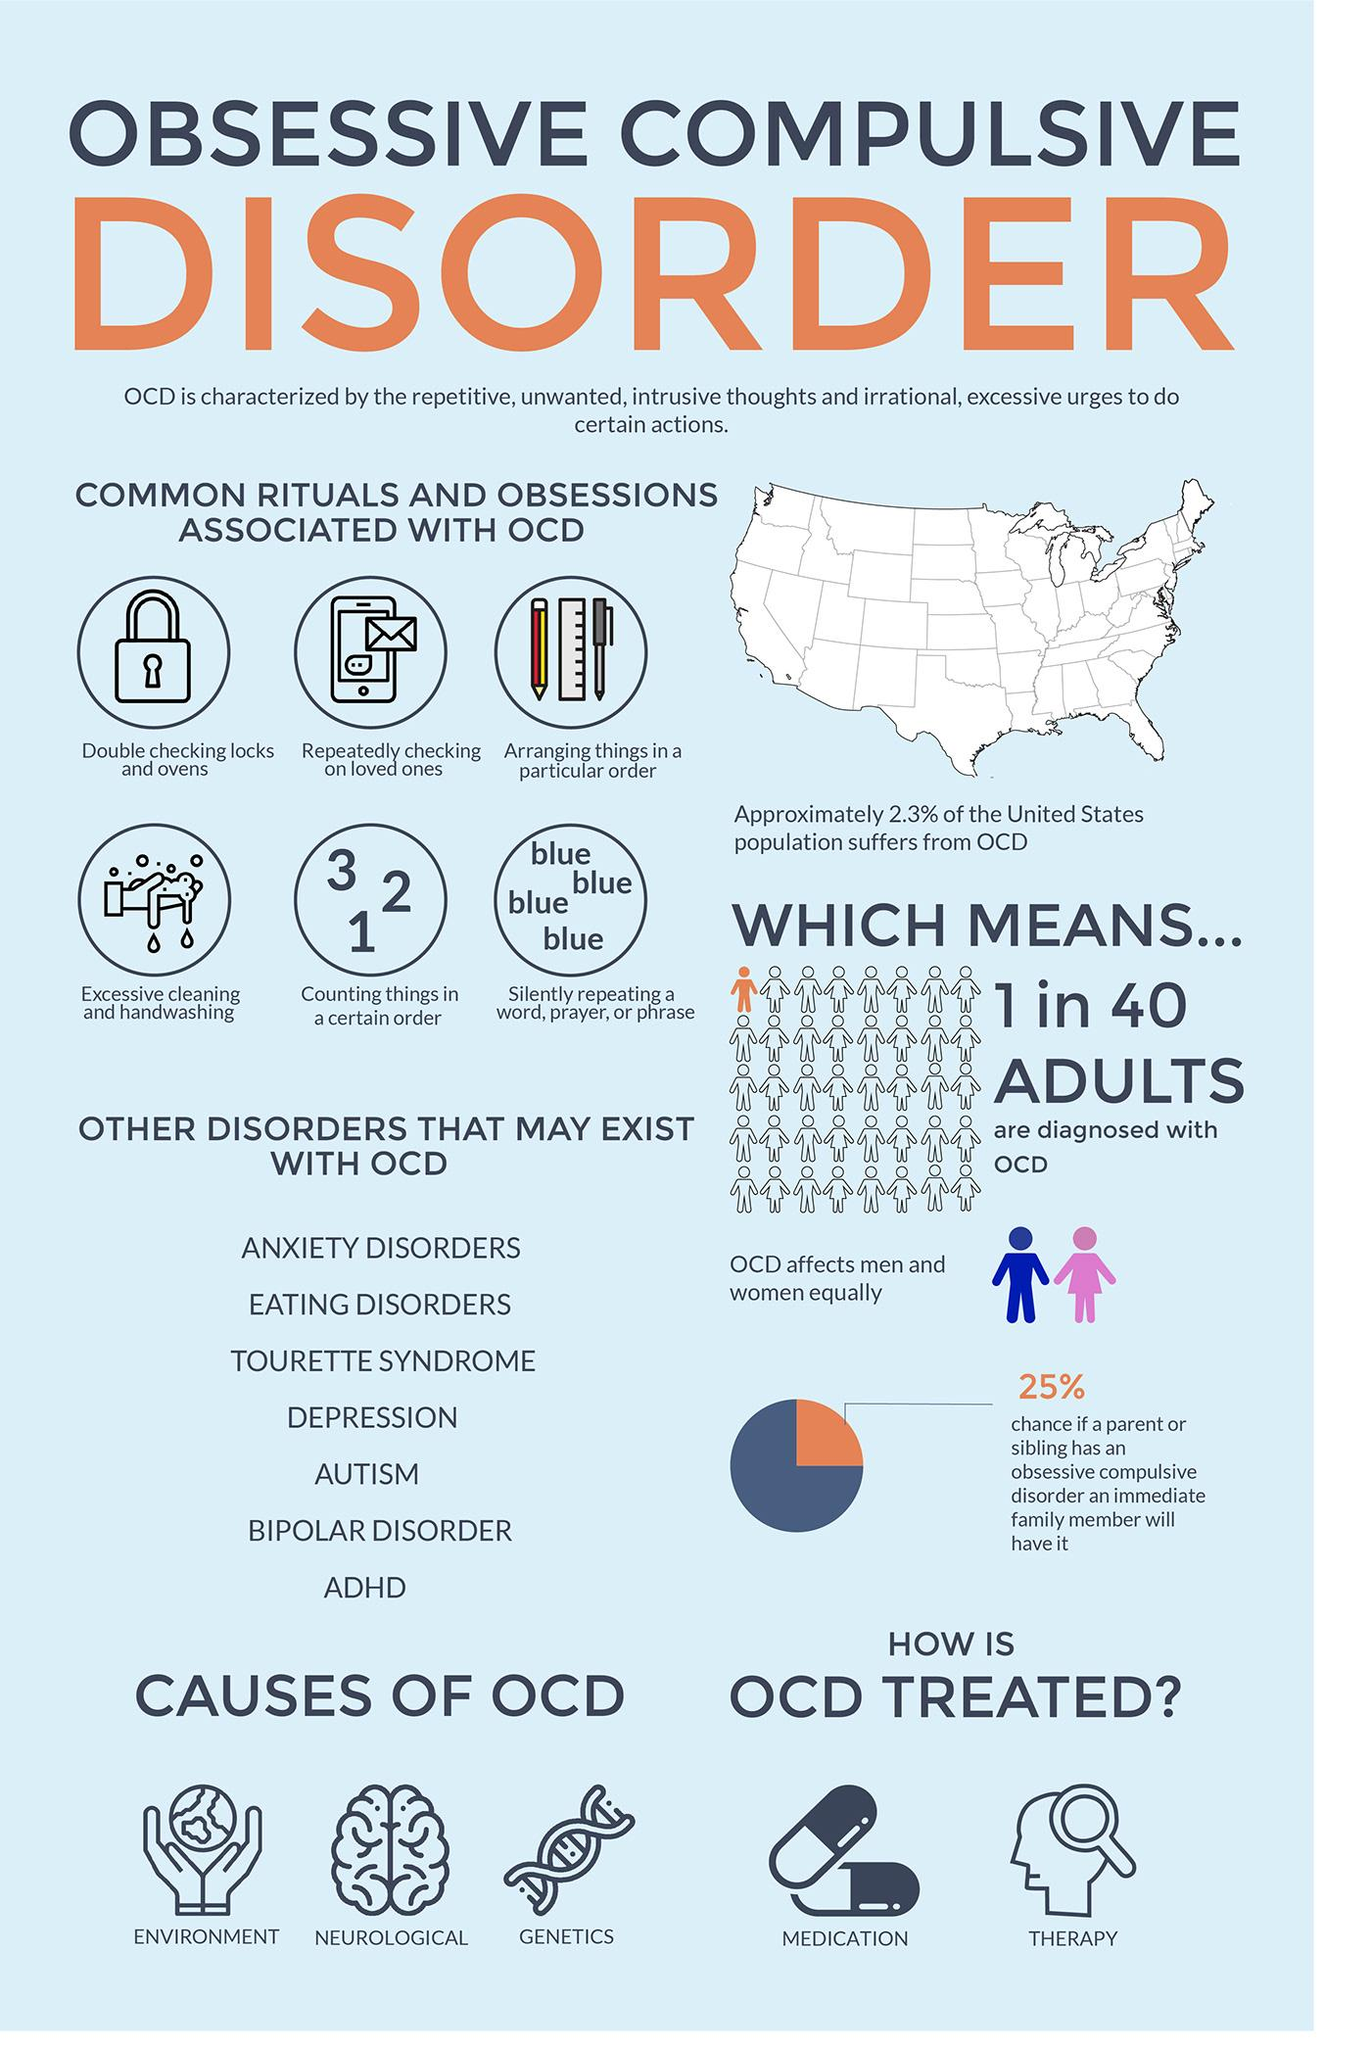Indicate a few pertinent items in this graphic. OCD is caused by a combination of environmental, neurological, and genetic factors. Treatments used for Obsessive-Compulsive Disorder (OCD) include medication and therapy. 